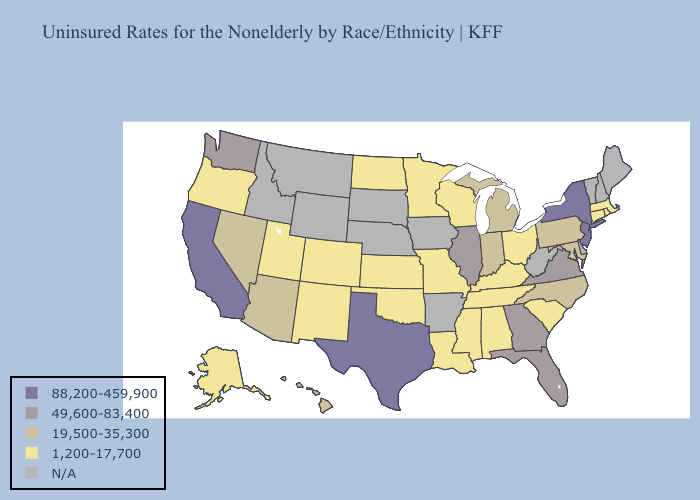Name the states that have a value in the range 49,600-83,400?
Answer briefly. Florida, Georgia, Illinois, Virginia, Washington. Does New Jersey have the lowest value in the Northeast?
Short answer required. No. Does Arizona have the lowest value in the West?
Give a very brief answer. No. Among the states that border Connecticut , which have the lowest value?
Concise answer only. Massachusetts, Rhode Island. Which states have the lowest value in the Northeast?
Keep it brief. Connecticut, Massachusetts, Rhode Island. What is the lowest value in states that border Pennsylvania?
Answer briefly. 1,200-17,700. What is the value of Rhode Island?
Short answer required. 1,200-17,700. Among the states that border Kentucky , which have the lowest value?
Short answer required. Missouri, Ohio, Tennessee. Name the states that have a value in the range N/A?
Quick response, please. Arkansas, Delaware, Idaho, Iowa, Maine, Montana, Nebraska, New Hampshire, South Dakota, Vermont, West Virginia, Wyoming. Among the states that border Colorado , does Arizona have the highest value?
Give a very brief answer. Yes. Name the states that have a value in the range 19,500-35,300?
Quick response, please. Arizona, Hawaii, Indiana, Maryland, Michigan, Nevada, North Carolina, Pennsylvania. What is the lowest value in the USA?
Quick response, please. 1,200-17,700. Name the states that have a value in the range 19,500-35,300?
Short answer required. Arizona, Hawaii, Indiana, Maryland, Michigan, Nevada, North Carolina, Pennsylvania. What is the value of Illinois?
Keep it brief. 49,600-83,400. Among the states that border Wyoming , which have the lowest value?
Keep it brief. Colorado, Utah. 